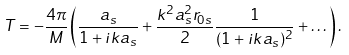Convert formula to latex. <formula><loc_0><loc_0><loc_500><loc_500>T = - \frac { 4 \pi } { M } \left ( \frac { a _ { s } } { 1 + i k a _ { s } } + \frac { k ^ { 2 } a _ { s } ^ { 2 } r _ { 0 s } } { 2 } \frac { 1 } { ( 1 + i k a _ { s } ) ^ { 2 } } + \dots \right ) .</formula> 